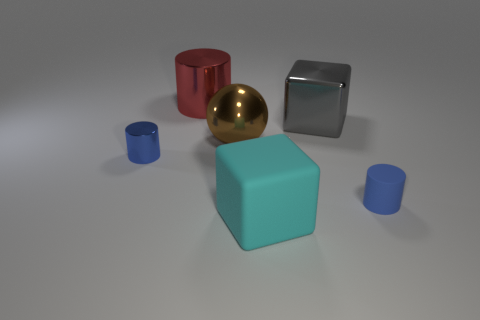Is the shape of the big red thing the same as the big cyan object?
Offer a very short reply. No. What number of big objects are either gray rubber things or gray metal cubes?
Your answer should be very brief. 1. What color is the tiny cylinder that is made of the same material as the big sphere?
Your answer should be compact. Blue. How many large brown objects have the same material as the red object?
Offer a very short reply. 1. Does the blue cylinder that is to the right of the red metal object have the same size as the shiny cylinder that is behind the brown metal sphere?
Provide a short and direct response. No. There is a small cylinder that is behind the cylinder to the right of the brown ball; what is it made of?
Offer a very short reply. Metal. Is the number of blocks that are in front of the big sphere less than the number of cyan matte blocks that are on the left side of the tiny blue matte cylinder?
Make the answer very short. No. There is another tiny object that is the same color as the small metallic thing; what is it made of?
Your response must be concise. Rubber. Is there anything else that has the same shape as the small blue metallic thing?
Provide a succinct answer. Yes. What material is the thing that is behind the big gray cube?
Your response must be concise. Metal. 